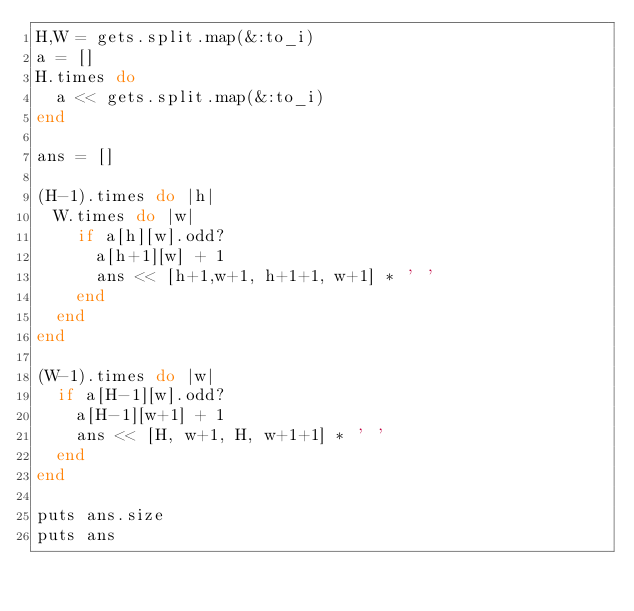<code> <loc_0><loc_0><loc_500><loc_500><_Ruby_>H,W = gets.split.map(&:to_i)
a = []
H.times do
  a << gets.split.map(&:to_i)
end

ans = []

(H-1).times do |h|
  W.times do |w|
    if a[h][w].odd?
      a[h+1][w] + 1
      ans << [h+1,w+1, h+1+1, w+1] * ' '
    end
  end
end

(W-1).times do |w|
  if a[H-1][w].odd?
    a[H-1][w+1] + 1
    ans << [H, w+1, H, w+1+1] * ' '
  end
end

puts ans.size
puts ans
</code> 